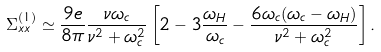Convert formula to latex. <formula><loc_0><loc_0><loc_500><loc_500>\Sigma ^ { ( 1 ) } _ { x x } \simeq \frac { 9 e } { 8 \pi } \frac { \nu \omega _ { c } } { \nu ^ { 2 } + \omega ^ { 2 } _ { c } } \left [ 2 - 3 \frac { \omega _ { H } } { \omega _ { c } } - \frac { 6 \omega _ { c } ( \omega _ { c } - \omega _ { H } ) } { \nu ^ { 2 } + \omega ^ { 2 } _ { c } } \right ] .</formula> 